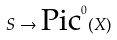<formula> <loc_0><loc_0><loc_500><loc_500>S \rightarrow { \text {Pic} } ^ { 0 } ( X )</formula> 